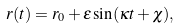<formula> <loc_0><loc_0><loc_500><loc_500>r ( t ) = r _ { 0 } + \varepsilon \sin ( \kappa t + \chi ) ,</formula> 